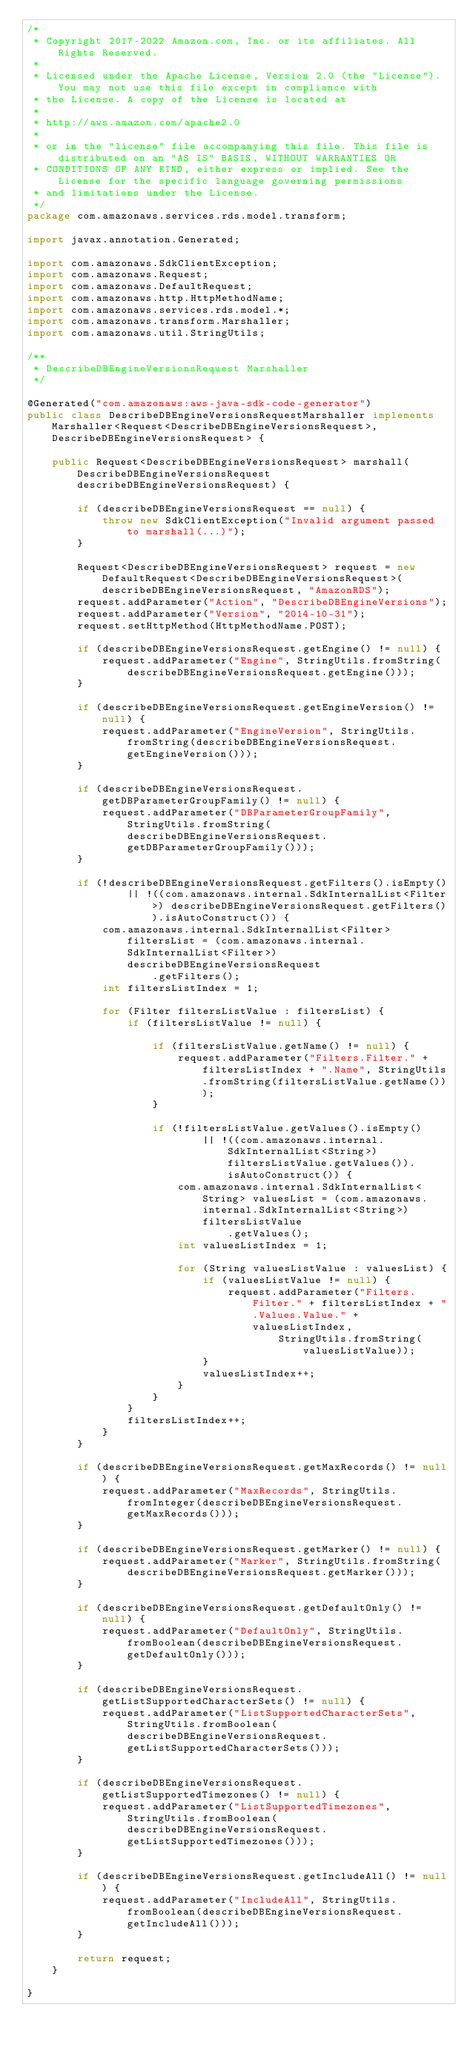<code> <loc_0><loc_0><loc_500><loc_500><_Java_>/*
 * Copyright 2017-2022 Amazon.com, Inc. or its affiliates. All Rights Reserved.
 * 
 * Licensed under the Apache License, Version 2.0 (the "License"). You may not use this file except in compliance with
 * the License. A copy of the License is located at
 * 
 * http://aws.amazon.com/apache2.0
 * 
 * or in the "license" file accompanying this file. This file is distributed on an "AS IS" BASIS, WITHOUT WARRANTIES OR
 * CONDITIONS OF ANY KIND, either express or implied. See the License for the specific language governing permissions
 * and limitations under the License.
 */
package com.amazonaws.services.rds.model.transform;

import javax.annotation.Generated;

import com.amazonaws.SdkClientException;
import com.amazonaws.Request;
import com.amazonaws.DefaultRequest;
import com.amazonaws.http.HttpMethodName;
import com.amazonaws.services.rds.model.*;
import com.amazonaws.transform.Marshaller;
import com.amazonaws.util.StringUtils;

/**
 * DescribeDBEngineVersionsRequest Marshaller
 */

@Generated("com.amazonaws:aws-java-sdk-code-generator")
public class DescribeDBEngineVersionsRequestMarshaller implements Marshaller<Request<DescribeDBEngineVersionsRequest>, DescribeDBEngineVersionsRequest> {

    public Request<DescribeDBEngineVersionsRequest> marshall(DescribeDBEngineVersionsRequest describeDBEngineVersionsRequest) {

        if (describeDBEngineVersionsRequest == null) {
            throw new SdkClientException("Invalid argument passed to marshall(...)");
        }

        Request<DescribeDBEngineVersionsRequest> request = new DefaultRequest<DescribeDBEngineVersionsRequest>(describeDBEngineVersionsRequest, "AmazonRDS");
        request.addParameter("Action", "DescribeDBEngineVersions");
        request.addParameter("Version", "2014-10-31");
        request.setHttpMethod(HttpMethodName.POST);

        if (describeDBEngineVersionsRequest.getEngine() != null) {
            request.addParameter("Engine", StringUtils.fromString(describeDBEngineVersionsRequest.getEngine()));
        }

        if (describeDBEngineVersionsRequest.getEngineVersion() != null) {
            request.addParameter("EngineVersion", StringUtils.fromString(describeDBEngineVersionsRequest.getEngineVersion()));
        }

        if (describeDBEngineVersionsRequest.getDBParameterGroupFamily() != null) {
            request.addParameter("DBParameterGroupFamily", StringUtils.fromString(describeDBEngineVersionsRequest.getDBParameterGroupFamily()));
        }

        if (!describeDBEngineVersionsRequest.getFilters().isEmpty()
                || !((com.amazonaws.internal.SdkInternalList<Filter>) describeDBEngineVersionsRequest.getFilters()).isAutoConstruct()) {
            com.amazonaws.internal.SdkInternalList<Filter> filtersList = (com.amazonaws.internal.SdkInternalList<Filter>) describeDBEngineVersionsRequest
                    .getFilters();
            int filtersListIndex = 1;

            for (Filter filtersListValue : filtersList) {
                if (filtersListValue != null) {

                    if (filtersListValue.getName() != null) {
                        request.addParameter("Filters.Filter." + filtersListIndex + ".Name", StringUtils.fromString(filtersListValue.getName()));
                    }

                    if (!filtersListValue.getValues().isEmpty()
                            || !((com.amazonaws.internal.SdkInternalList<String>) filtersListValue.getValues()).isAutoConstruct()) {
                        com.amazonaws.internal.SdkInternalList<String> valuesList = (com.amazonaws.internal.SdkInternalList<String>) filtersListValue
                                .getValues();
                        int valuesListIndex = 1;

                        for (String valuesListValue : valuesList) {
                            if (valuesListValue != null) {
                                request.addParameter("Filters.Filter." + filtersListIndex + ".Values.Value." + valuesListIndex,
                                        StringUtils.fromString(valuesListValue));
                            }
                            valuesListIndex++;
                        }
                    }
                }
                filtersListIndex++;
            }
        }

        if (describeDBEngineVersionsRequest.getMaxRecords() != null) {
            request.addParameter("MaxRecords", StringUtils.fromInteger(describeDBEngineVersionsRequest.getMaxRecords()));
        }

        if (describeDBEngineVersionsRequest.getMarker() != null) {
            request.addParameter("Marker", StringUtils.fromString(describeDBEngineVersionsRequest.getMarker()));
        }

        if (describeDBEngineVersionsRequest.getDefaultOnly() != null) {
            request.addParameter("DefaultOnly", StringUtils.fromBoolean(describeDBEngineVersionsRequest.getDefaultOnly()));
        }

        if (describeDBEngineVersionsRequest.getListSupportedCharacterSets() != null) {
            request.addParameter("ListSupportedCharacterSets", StringUtils.fromBoolean(describeDBEngineVersionsRequest.getListSupportedCharacterSets()));
        }

        if (describeDBEngineVersionsRequest.getListSupportedTimezones() != null) {
            request.addParameter("ListSupportedTimezones", StringUtils.fromBoolean(describeDBEngineVersionsRequest.getListSupportedTimezones()));
        }

        if (describeDBEngineVersionsRequest.getIncludeAll() != null) {
            request.addParameter("IncludeAll", StringUtils.fromBoolean(describeDBEngineVersionsRequest.getIncludeAll()));
        }

        return request;
    }

}
</code> 